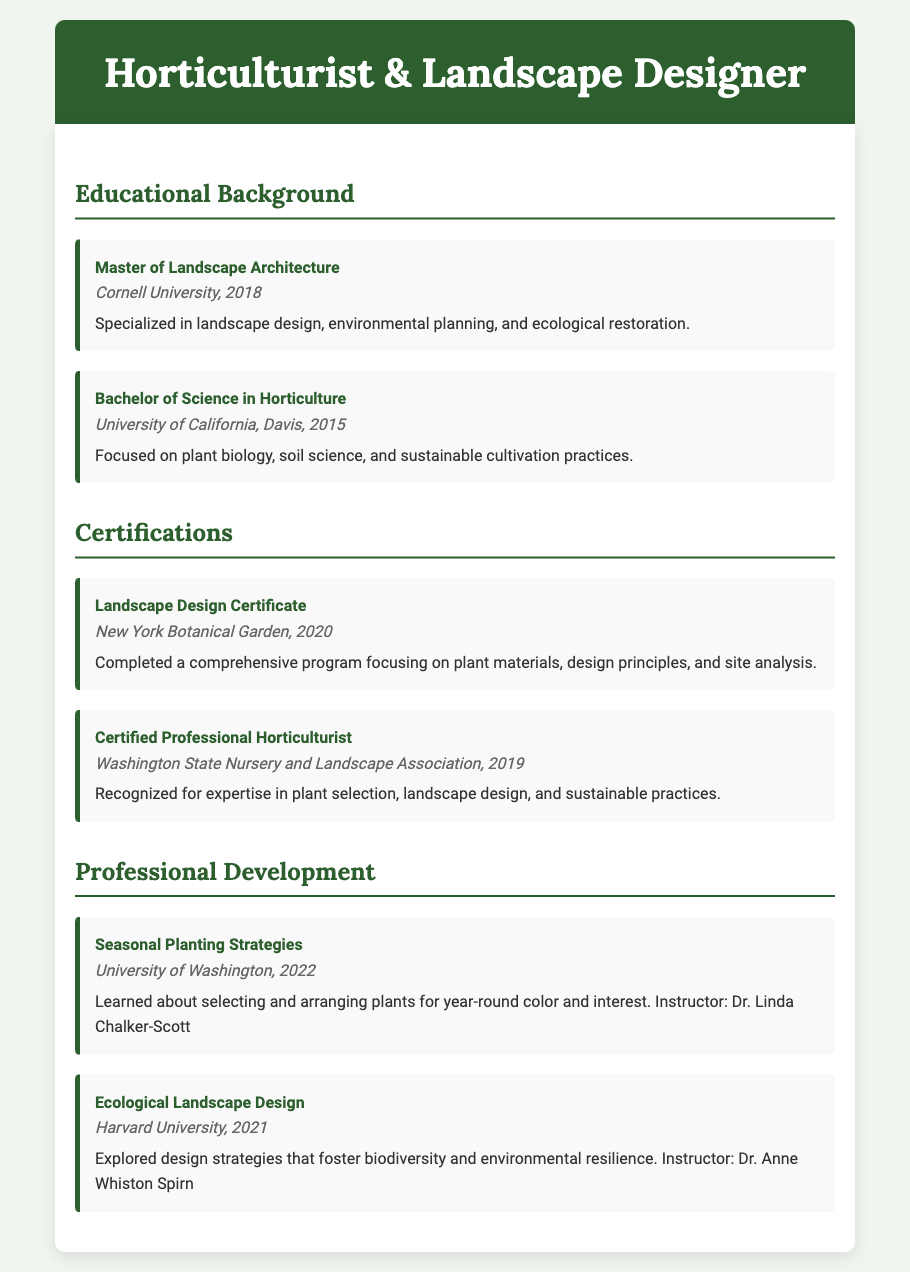What degree did the horticulturist earn at Cornell University? The document states that the horticulturist earned a Master of Landscape Architecture at Cornell University in 2018.
Answer: Master of Landscape Architecture What was the focus of the Bachelor of Science in Horticulture? The document mentions that the focus was on plant biology, soil science, and sustainable cultivation practices.
Answer: Plant biology, soil science, sustainable cultivation practices In what year was the Landscape Design Certificate obtained? The document indicates that the Landscape Design Certificate was completed in 2020.
Answer: 2020 Who awarded the Certified Professional Horticulturist title? According to the document, it was awarded by the Washington State Nursery and Landscape Association.
Answer: Washington State Nursery and Landscape Association What is the title of the 2022 professional development course? The document lists "Seasonal Planting Strategies" as the title of the course in 2022.
Answer: Seasonal Planting Strategies What institution awarded the professional development course on Ecological Landscape Design? The document states that Harvard University offered the Ecological Landscape Design course.
Answer: Harvard University What was the primary specialization of the Master's program? The document specifies that the specialization was in landscape design, environmental planning, and ecological restoration.
Answer: Landscape design, environmental planning, ecological restoration How many years apart were the Bachelor of Science and Master's degrees earned? The document states that the Bachelor's degree was earned in 2015 and the Master's in 2018; therefore, they are three years apart.
Answer: 3 years What is one of the topics covered in the Seasonal Planting Strategies course? The document mentions learning about selecting and arranging plants for year-round color and interest.
Answer: Year-round color and interest 